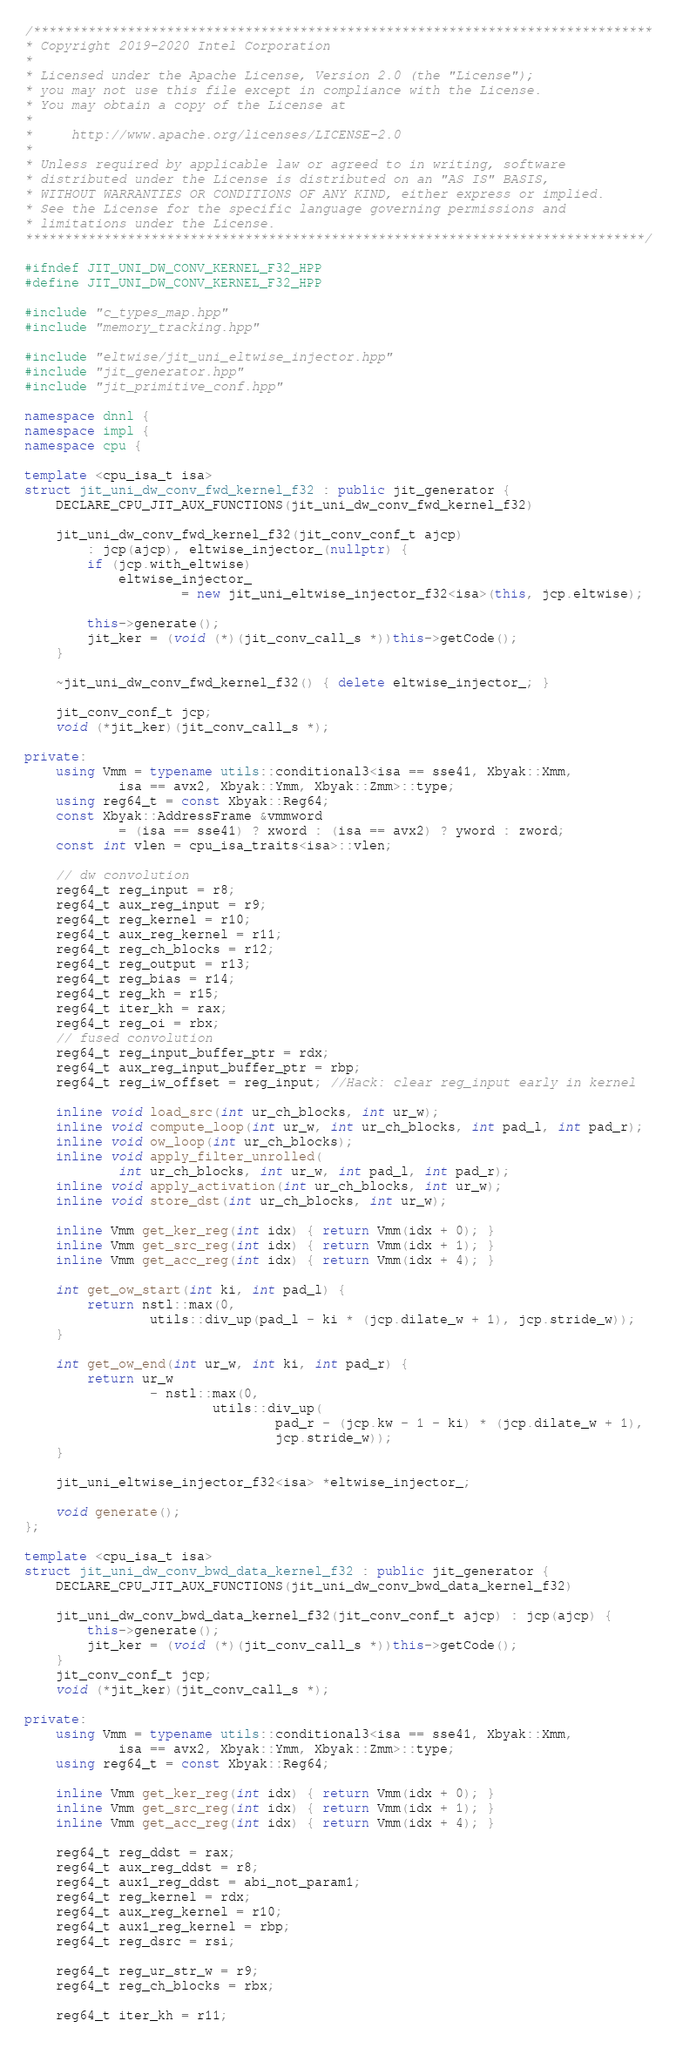Convert code to text. <code><loc_0><loc_0><loc_500><loc_500><_C++_>/*******************************************************************************
* Copyright 2019-2020 Intel Corporation
*
* Licensed under the Apache License, Version 2.0 (the "License");
* you may not use this file except in compliance with the License.
* You may obtain a copy of the License at
*
*     http://www.apache.org/licenses/LICENSE-2.0
*
* Unless required by applicable law or agreed to in writing, software
* distributed under the License is distributed on an "AS IS" BASIS,
* WITHOUT WARRANTIES OR CONDITIONS OF ANY KIND, either express or implied.
* See the License for the specific language governing permissions and
* limitations under the License.
*******************************************************************************/

#ifndef JIT_UNI_DW_CONV_KERNEL_F32_HPP
#define JIT_UNI_DW_CONV_KERNEL_F32_HPP

#include "c_types_map.hpp"
#include "memory_tracking.hpp"

#include "eltwise/jit_uni_eltwise_injector.hpp"
#include "jit_generator.hpp"
#include "jit_primitive_conf.hpp"

namespace dnnl {
namespace impl {
namespace cpu {

template <cpu_isa_t isa>
struct jit_uni_dw_conv_fwd_kernel_f32 : public jit_generator {
    DECLARE_CPU_JIT_AUX_FUNCTIONS(jit_uni_dw_conv_fwd_kernel_f32)

    jit_uni_dw_conv_fwd_kernel_f32(jit_conv_conf_t ajcp)
        : jcp(ajcp), eltwise_injector_(nullptr) {
        if (jcp.with_eltwise)
            eltwise_injector_
                    = new jit_uni_eltwise_injector_f32<isa>(this, jcp.eltwise);

        this->generate();
        jit_ker = (void (*)(jit_conv_call_s *))this->getCode();
    }

    ~jit_uni_dw_conv_fwd_kernel_f32() { delete eltwise_injector_; }

    jit_conv_conf_t jcp;
    void (*jit_ker)(jit_conv_call_s *);

private:
    using Vmm = typename utils::conditional3<isa == sse41, Xbyak::Xmm,
            isa == avx2, Xbyak::Ymm, Xbyak::Zmm>::type;
    using reg64_t = const Xbyak::Reg64;
    const Xbyak::AddressFrame &vmmword
            = (isa == sse41) ? xword : (isa == avx2) ? yword : zword;
    const int vlen = cpu_isa_traits<isa>::vlen;

    // dw convolution
    reg64_t reg_input = r8;
    reg64_t aux_reg_input = r9;
    reg64_t reg_kernel = r10;
    reg64_t aux_reg_kernel = r11;
    reg64_t reg_ch_blocks = r12;
    reg64_t reg_output = r13;
    reg64_t reg_bias = r14;
    reg64_t reg_kh = r15;
    reg64_t iter_kh = rax;
    reg64_t reg_oi = rbx;
    // fused convolution
    reg64_t reg_input_buffer_ptr = rdx;
    reg64_t aux_reg_input_buffer_ptr = rbp;
    reg64_t reg_iw_offset = reg_input; //Hack: clear reg_input early in kernel

    inline void load_src(int ur_ch_blocks, int ur_w);
    inline void compute_loop(int ur_w, int ur_ch_blocks, int pad_l, int pad_r);
    inline void ow_loop(int ur_ch_blocks);
    inline void apply_filter_unrolled(
            int ur_ch_blocks, int ur_w, int pad_l, int pad_r);
    inline void apply_activation(int ur_ch_blocks, int ur_w);
    inline void store_dst(int ur_ch_blocks, int ur_w);

    inline Vmm get_ker_reg(int idx) { return Vmm(idx + 0); }
    inline Vmm get_src_reg(int idx) { return Vmm(idx + 1); }
    inline Vmm get_acc_reg(int idx) { return Vmm(idx + 4); }

    int get_ow_start(int ki, int pad_l) {
        return nstl::max(0,
                utils::div_up(pad_l - ki * (jcp.dilate_w + 1), jcp.stride_w));
    }

    int get_ow_end(int ur_w, int ki, int pad_r) {
        return ur_w
                - nstl::max(0,
                        utils::div_up(
                                pad_r - (jcp.kw - 1 - ki) * (jcp.dilate_w + 1),
                                jcp.stride_w));
    }

    jit_uni_eltwise_injector_f32<isa> *eltwise_injector_;

    void generate();
};

template <cpu_isa_t isa>
struct jit_uni_dw_conv_bwd_data_kernel_f32 : public jit_generator {
    DECLARE_CPU_JIT_AUX_FUNCTIONS(jit_uni_dw_conv_bwd_data_kernel_f32)

    jit_uni_dw_conv_bwd_data_kernel_f32(jit_conv_conf_t ajcp) : jcp(ajcp) {
        this->generate();
        jit_ker = (void (*)(jit_conv_call_s *))this->getCode();
    }
    jit_conv_conf_t jcp;
    void (*jit_ker)(jit_conv_call_s *);

private:
    using Vmm = typename utils::conditional3<isa == sse41, Xbyak::Xmm,
            isa == avx2, Xbyak::Ymm, Xbyak::Zmm>::type;
    using reg64_t = const Xbyak::Reg64;

    inline Vmm get_ker_reg(int idx) { return Vmm(idx + 0); }
    inline Vmm get_src_reg(int idx) { return Vmm(idx + 1); }
    inline Vmm get_acc_reg(int idx) { return Vmm(idx + 4); }

    reg64_t reg_ddst = rax;
    reg64_t aux_reg_ddst = r8;
    reg64_t aux1_reg_ddst = abi_not_param1;
    reg64_t reg_kernel = rdx;
    reg64_t aux_reg_kernel = r10;
    reg64_t aux1_reg_kernel = rbp;
    reg64_t reg_dsrc = rsi;

    reg64_t reg_ur_str_w = r9;
    reg64_t reg_ch_blocks = rbx;

    reg64_t iter_kh = r11;</code> 